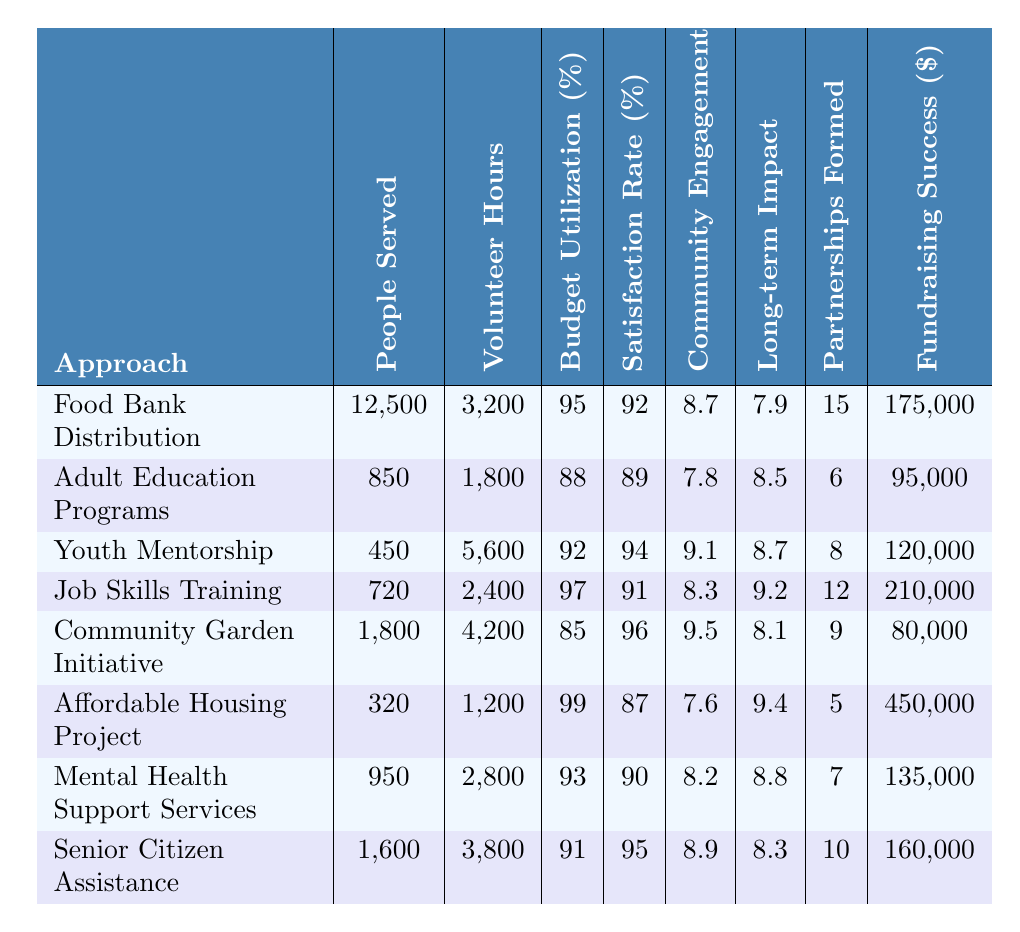What approach served the highest number of people? The "Food Bank Distribution" approach served 12,500 people, which is the highest number when compared to all other approaches listed in the table.
Answer: Food Bank Distribution What is the satisfaction rate of the Community Garden Initiative? The satisfaction rate for the "Community Garden Initiative" is 96%, which can be found in the corresponding row in the table.
Answer: 96% Which approach had the lowest budget utilization percentage? The "Community Garden Initiative" had the lowest budget utilization percentage at 85%. This can be observed directly by comparing the budget utilization percentages for all approaches.
Answer: Community Garden Initiative How many volunteer hours were contributed to the Youth Mentorship program? The "Youth Mentorship" program had 5,600 volunteer hours, as indicated in the table.
Answer: 5600 What is the total fundraising success for all approaches combined? To calculate the total fundraising success, add the fundraising amounts: 175,000 + 95,000 + 120,000 + 210,000 + 80,000 + 450,000 + 135,000 + 160,000 = 1,270,000.
Answer: 1,270,000 What is the average long-term impact score of the programs? To find the average long-term impact score, sum the scores: 7.9 + 8.5 + 8.7 + 9.2 + 8.1 + 9.4 + 8.8 + 8.3 = 70.9. Divide by the number of programs (8) to get 70.9 / 8 = 8.8625, which rounds to 8.86.
Answer: 8.86 Is the satisfaction rate of the Affordable Housing Project above 85%? Yes, the satisfaction rate for the "Affordable Housing Project" is 87%, which is indeed above 85%.
Answer: Yes Which approach had the highest number of partnerships formed? The "Food Bank Distribution" approach formed the most partnerships, with a total of 15 partnerships, as indicated in the table.
Answer: Food Bank Distribution What is the difference in volunteer hours between Youth Mentorship and Affordable Housing Project? The difference in volunteer hours is calculated by subtracting the volunteer hours of Affordable Housing Project (1,200) from Youth Mentorship (5,600). The difference is 5,600 - 1,200 = 4,400 hours.
Answer: 4,400 Which approach had both a budget utilization of over 95% and a satisfaction rate of over 90%? "Job Skills Training" meets both criteria with a budget utilization of 97% and a satisfaction rate of 91%. Therefore, it is the approach that qualifies.
Answer: Job Skills Training 